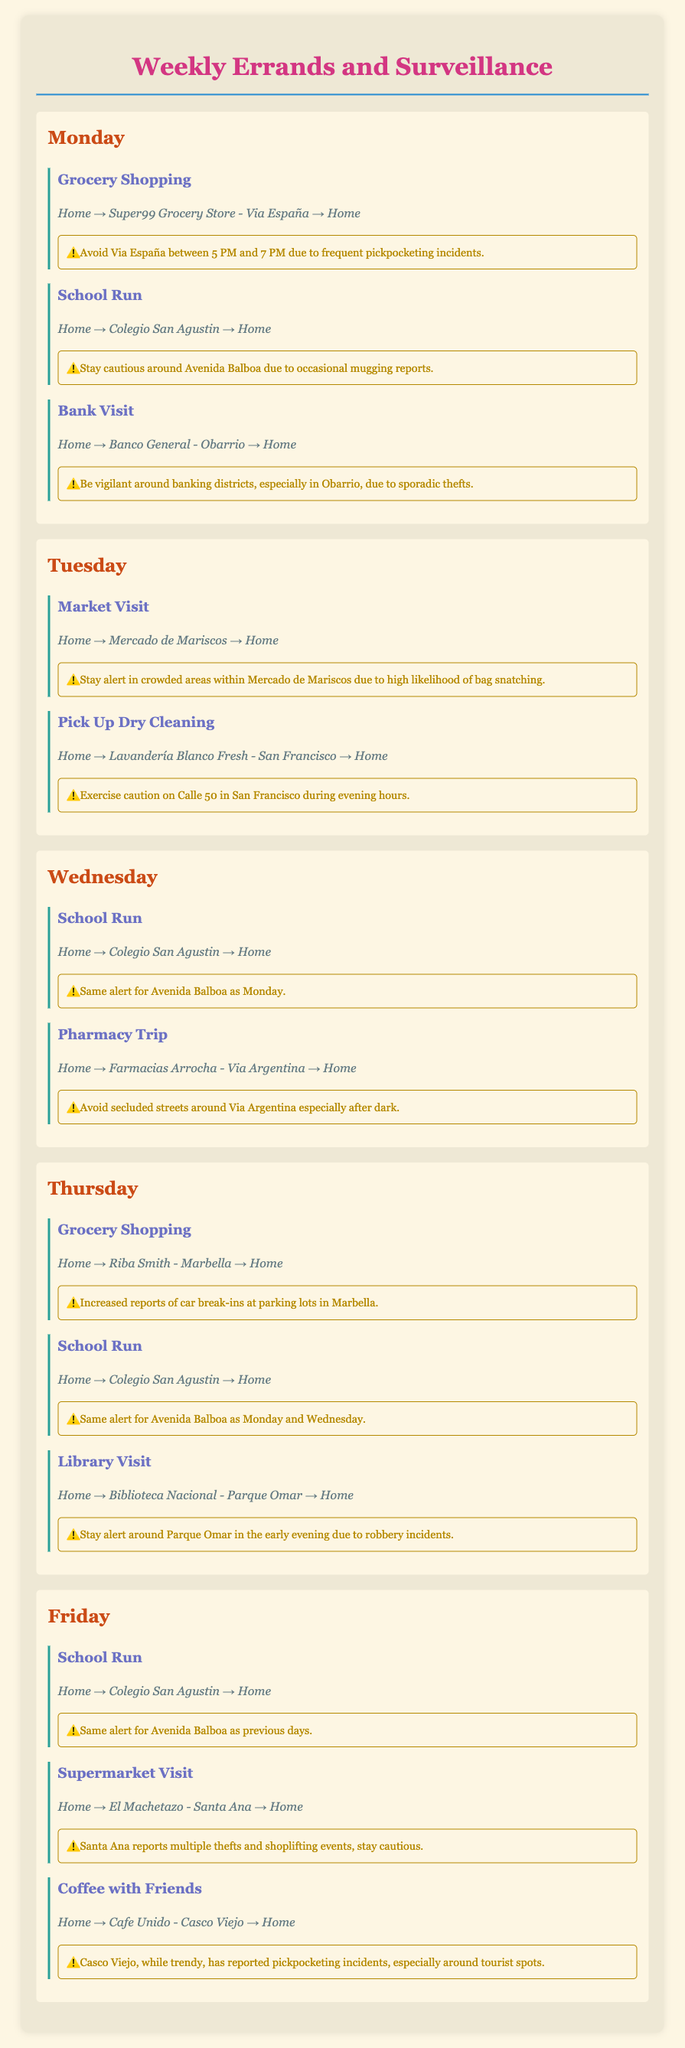What is the name of the grocery store visited on Monday? The grocery store visited on Monday is Super99 Grocery Store.
Answer: Super99 Grocery Store What route is taken for the school run on Wednesday? The route for the school run on Wednesday is Home → Colegio San Agustin → Home.
Answer: Home → Colegio San Agustin → Home Which day includes a visit to the Biblioteca Nacional? The day that includes a visit to the Biblioteca Nacional is Thursday.
Answer: Thursday What time should you avoid Via España due to crime alerts? You should avoid Via España between 5 PM and 7 PM due to crime alerts.
Answer: 5 PM and 7 PM How many school runs are scheduled per week? There are four school runs scheduled per week, one on Monday, Wednesday, Thursday, and Friday.
Answer: Four What precautions should be taken during the market visit? You should stay alert in crowded areas within Mercado de Mariscos due to a high likelihood of bag snatching.
Answer: Stay alert in crowded areas What is the alert for the supermarket visit on Friday? The alert for the supermarket visit on Friday indicates multiple thefts and shoplifting events.
Answer: Multiple thefts and shoplifting events Which area is mentioned for increased reports of car break-ins? The area mentioned for increased reports of car break-ins is Marbella.
Answer: Marbella On what day is the coffee with friends scheduled? The coffee with friends is scheduled for Friday.
Answer: Friday 